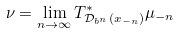<formula> <loc_0><loc_0><loc_500><loc_500>\nu = \lim _ { n \rightarrow \infty } T _ { \mathcal { D } _ { b ^ { n } } ( x _ { - n } ) } ^ { * } \mu _ { - n }</formula> 